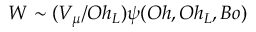<formula> <loc_0><loc_0><loc_500><loc_500>W \sim ( V _ { \mu } / O h _ { L } ) \psi ( O h , O h _ { L } , B o )</formula> 